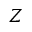<formula> <loc_0><loc_0><loc_500><loc_500>Z</formula> 